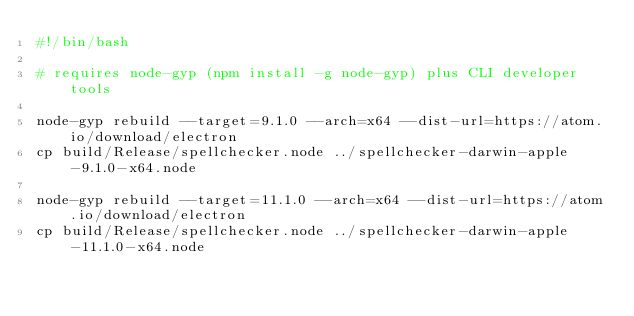Convert code to text. <code><loc_0><loc_0><loc_500><loc_500><_Bash_>#!/bin/bash

# requires node-gyp (npm install -g node-gyp) plus CLI developer tools

node-gyp rebuild --target=9.1.0 --arch=x64 --dist-url=https://atom.io/download/electron
cp build/Release/spellchecker.node ../spellchecker-darwin-apple-9.1.0-x64.node

node-gyp rebuild --target=11.1.0 --arch=x64 --dist-url=https://atom.io/download/electron
cp build/Release/spellchecker.node ../spellchecker-darwin-apple-11.1.0-x64.node
</code> 